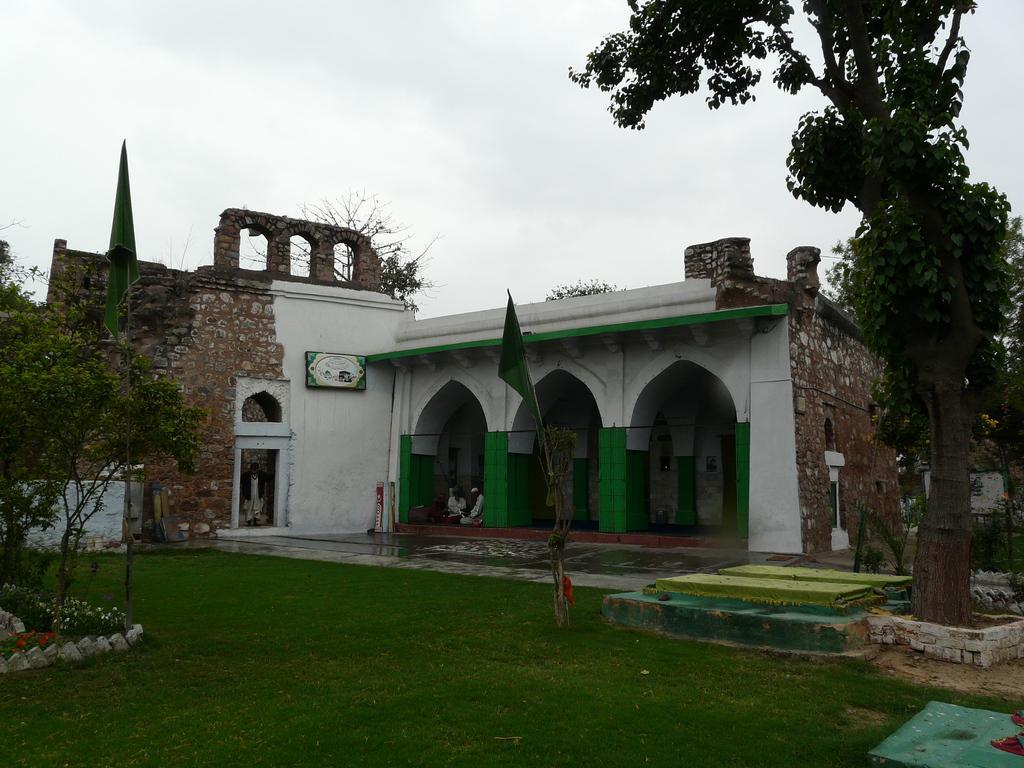How would you summarize this image in a sentence or two? In the center of the image we can see building, wall, some persons, flags, poles, trees, board. At the bottom of the image we can see ground, bricks, plants, flowers. At the top of the image we can see clouds are present in the sky. 